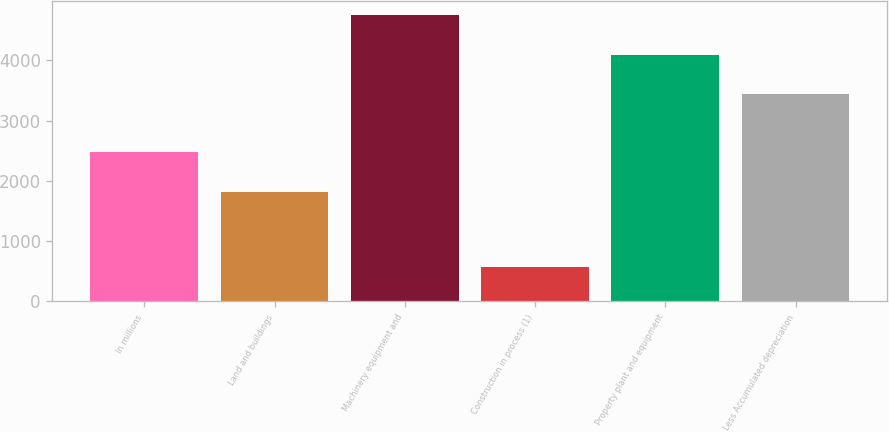Convert chart to OTSL. <chart><loc_0><loc_0><loc_500><loc_500><bar_chart><fcel>In millions<fcel>Land and buildings<fcel>Machinery equipment and<fcel>Construction in process (1)<fcel>Property plant and equipment<fcel>Less Accumulated depreciation<nl><fcel>2476.4<fcel>1822<fcel>4745.8<fcel>579<fcel>4091.4<fcel>3437<nl></chart> 